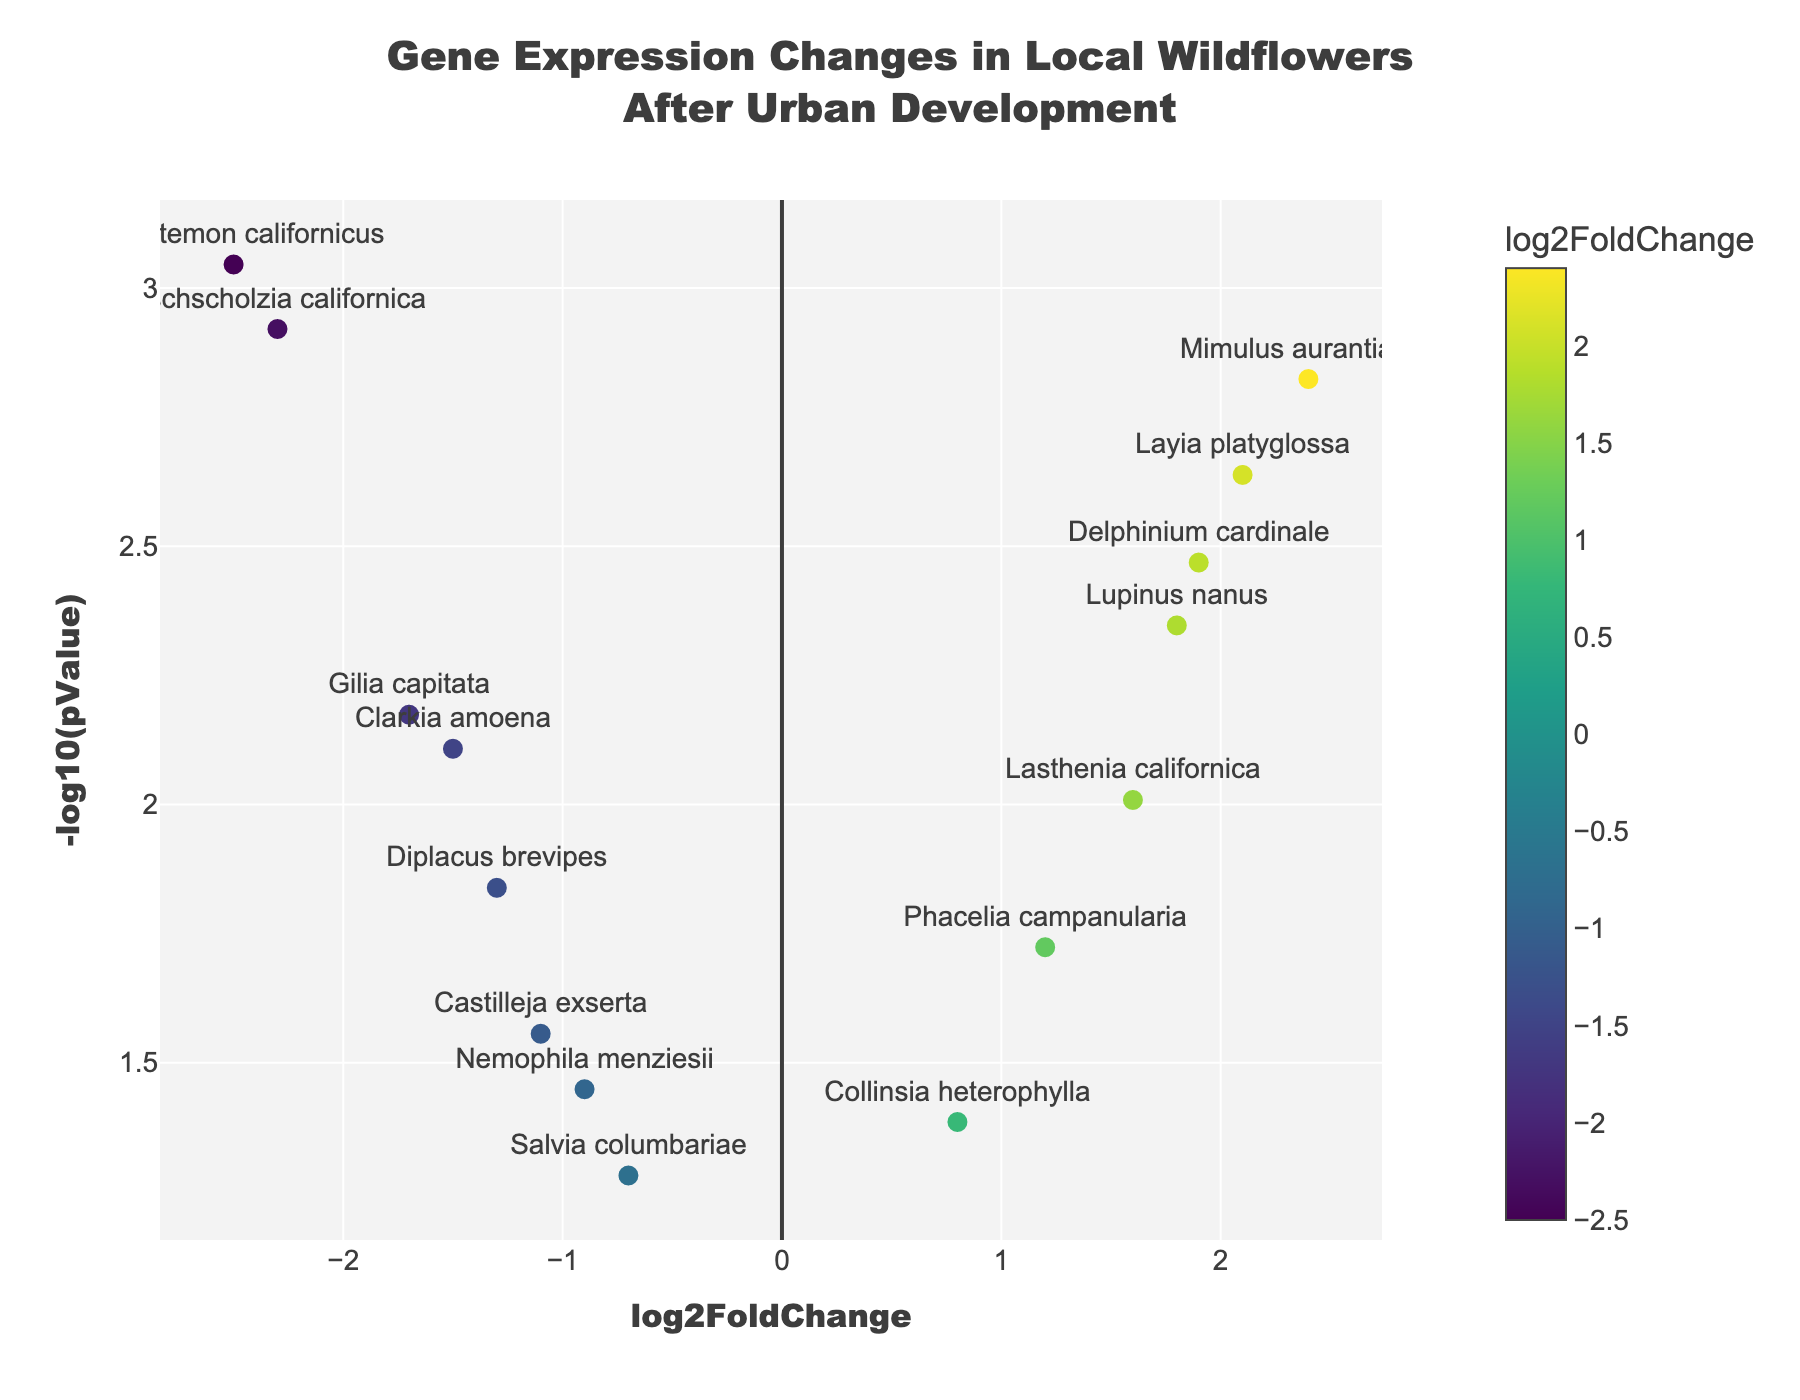What is the title of the plot? The title is placed at the top center and reads "Gene Expression Changes in Local Wildflowers After Urban Development".
Answer: Gene Expression Changes in Local Wildflowers After Urban Development What does the x-axis represent? The x-axis is labeled as "log2FoldChange", indicating it represents the log base 2 fold change in gene expression.
Answer: log2FoldChange What does the y-axis represent? The y-axis is labeled as "-log10(pValue)", showing it represents the negative log base 10 of the p-value.
Answer: -log10(pValue) How many genes show a negative log2FoldChange? By examining the x-axis, any gene with a log2FoldChange less than 0 is plotted on the left side; counting these points gives the number of genes with negative log2FoldChange. There are 7 such genes.
Answer: 7 Which gene has the most significant p-value? The most significant p-value corresponds to the highest -log10(pValue) value. "Platystemon californicus" has the highest -log10(pValue) value, indicating the most significant p-value.
Answer: Platystemon californicus Which gene shows the highest log2FoldChange? By finding the gene with the highest value on the x-axis, "Mimulus aurantiacus" displays the highest log2FoldChange of 2.4.
Answer: Mimulus aurantiacus What is the log2FoldChange and p-value for "Eschscholzia californica"? The point labeled "Eschscholzia californica" has a log2FoldChange of -2.3 and a p-value of 0.0012 (found by tracing the hover text).
Answer: -2.3, 0.0012 Compare the log2FoldChange between "Lupinus nanus" and "Salvia columbariae". Which one is greater? "Lupinus nanus" has a log2FoldChange of 1.8, while "Salvia columbariae" has a log2FoldChange of -0.7. Clearly, 1.8 is greater than -0.7.
Answer: Lupinus nanus Are there more genes with log2FoldChange greater than 1 or less than -1? Counting the points with log2FoldChange > 1 (4 genes) and those with log2FoldChange < -1 (6 genes), there are more genes with log2FoldChange less than -1.
Answer: Less than -1 What color represents the highest log2FoldChange, and which gene does it correspond to? The color scale marks the highest log2FoldChange with the brightest color, which corresponds to "Mimulus aurantiacus".
Answer: Brightest color, Mimulus aurantiacus 